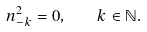Convert formula to latex. <formula><loc_0><loc_0><loc_500><loc_500>n ^ { 2 } _ { - k } = 0 , \quad k \in \mathbb { N } .</formula> 